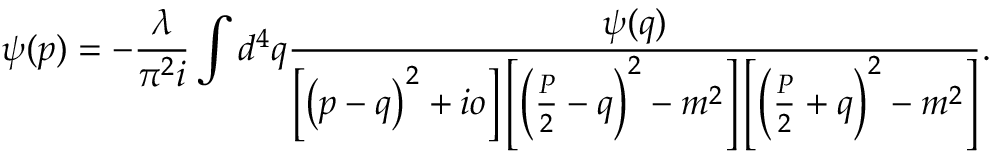Convert formula to latex. <formula><loc_0><loc_0><loc_500><loc_500>\psi ( p ) = - \frac { \lambda } { \pi ^ { 2 } i } \int d ^ { 4 } q \frac { \psi ( q ) } { \left [ \left ( p - q \right ) ^ { 2 } + i o \right ] \left [ \left ( \frac { P } { 2 } - q \right ) ^ { 2 } - m ^ { 2 } \right ] \left [ \left ( \frac { P } { 2 } + q \right ) ^ { 2 } - m ^ { 2 } \right ] } .</formula> 